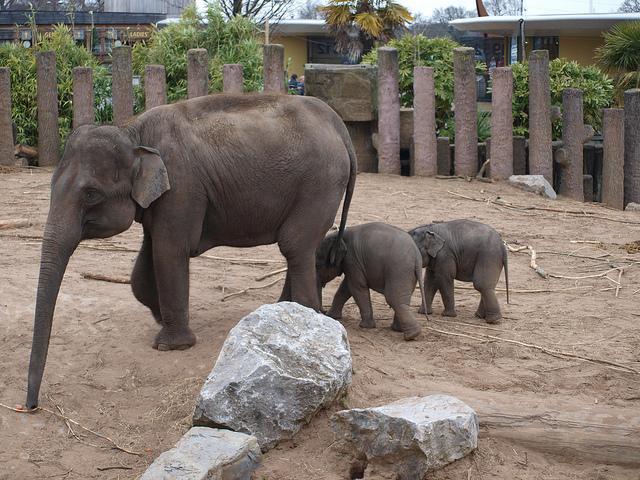How many rocks are in the picture?
Give a very brief answer. 4. How many baby elephants are in the picture?
Give a very brief answer. 2. How many elephants are in the picture?
Give a very brief answer. 3. How many elephants are here?
Give a very brief answer. 3. How many elephants are there?
Give a very brief answer. 3. How many ovens is there?
Give a very brief answer. 0. 